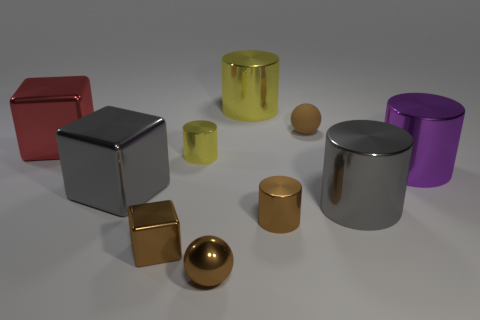What number of things are small brown cylinders or big shiny objects that are left of the tiny yellow thing?
Make the answer very short. 3. What size is the gray cylinder that is made of the same material as the purple cylinder?
Ensure brevity in your answer.  Large. What number of brown things are either shiny cubes or big shiny things?
Your answer should be very brief. 1. What is the shape of the matte thing that is the same color as the tiny shiny ball?
Your answer should be compact. Sphere. Are there any other things that have the same material as the gray cube?
Keep it short and to the point. Yes. Is the shape of the small brown rubber object that is behind the big purple cylinder the same as the small thing that is in front of the brown cube?
Your answer should be very brief. Yes. How many tiny cylinders are there?
Keep it short and to the point. 2. What is the shape of the other yellow thing that is made of the same material as the small yellow object?
Give a very brief answer. Cylinder. Is there anything else of the same color as the tiny rubber thing?
Offer a very short reply. Yes. There is a metal sphere; does it have the same color as the tiny shiny object that is on the right side of the shiny sphere?
Your answer should be very brief. Yes. 